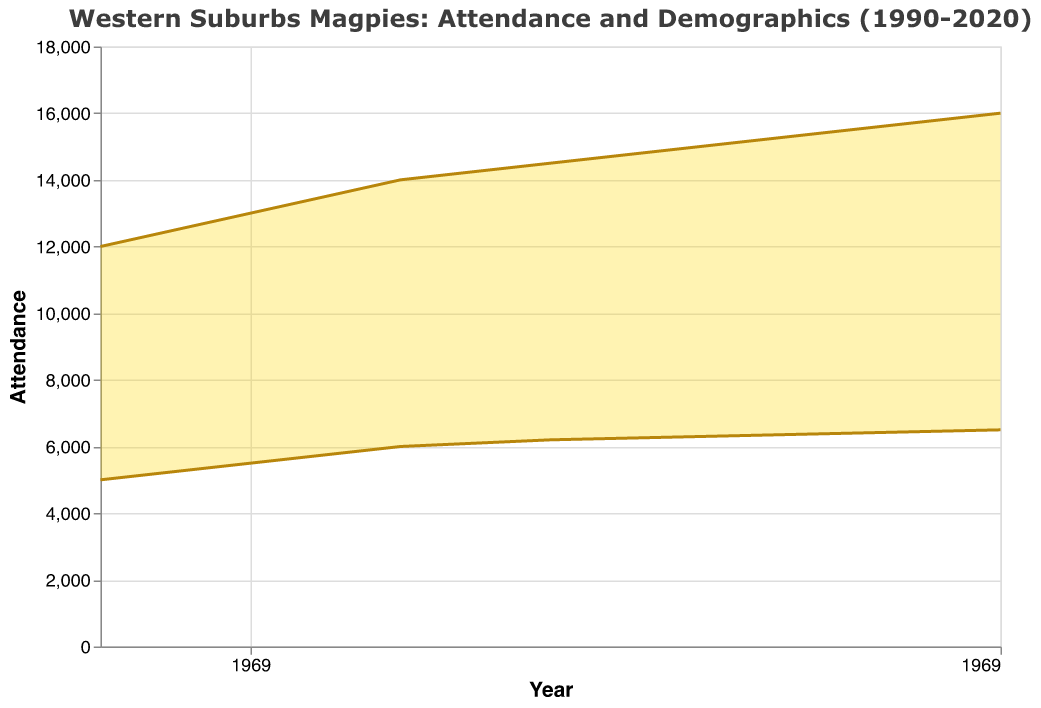What is the title of the chart? The title of the chart is located at the top and reads "Western Suburbs Magpies: Attendance and Demographics (1990-2020)."
Answer: Western Suburbs Magpies: Attendance and Demographics (1990-2020) What do the two different colored elements (gold and dark gold) represent in the chart? The gold area represents the range between minimum and maximum attendance, and the dark gold lines represent the trends of the minimum and maximum attendance over the years.
Answer: Attendance values over the years How did the maximum attendance change from 1990 to 2020? By looking at the dark gold line for the maximum attendance, it increased from 12,000 in 1990 to 16,000 in 2020.
Answer: Increased from 12,000 to 16,000 What is the range of attendance in the year 2000? The gold area in the year 2000 represents the range of attendance, which spans from 6,000 (min) to 14,000 (max).
Answer: 6,000 to 14,000 What is the average of the minimum attendance in 1990 and 2020? The minimum attendance is 5,000 in 1990 and 6,500 in 2020. The average is (5,000 + 6,500) / 2.
Answer: 5,750 By how much did the minimum attendance increase from 1990 to 2020? The minimum attendance increased from 5,000 in 1990 to 6,500 in 2020. The difference is 6,500 - 5,000.
Answer: 1,500 Comparing 1995 to 2005, how much did the maximum attendance increase? The maximum attendance in 1995 was 13,000 and in 2005 it was 14,500. The increase is 14,500 - 13,000.
Answer: 1,500 What trend is observed in the maximum attendance from 1990 to 2020? The trend shows a consistent increase in the maximum attendance over the period from 1990 to 2020.
Answer: Consistent increase What is the average of the maximum attendance over the years 1990, 2000, and 2010? The maximum attendances for these years are 12,000, 14,000, and 15,000 respectively. The average is (12,000 + 14,000 + 15,000) / 3.
Answer: 13,670 What is the range of years covered in the chart? The x-axis shows years from 1990 to 2020.
Answer: 1990 to 2020 